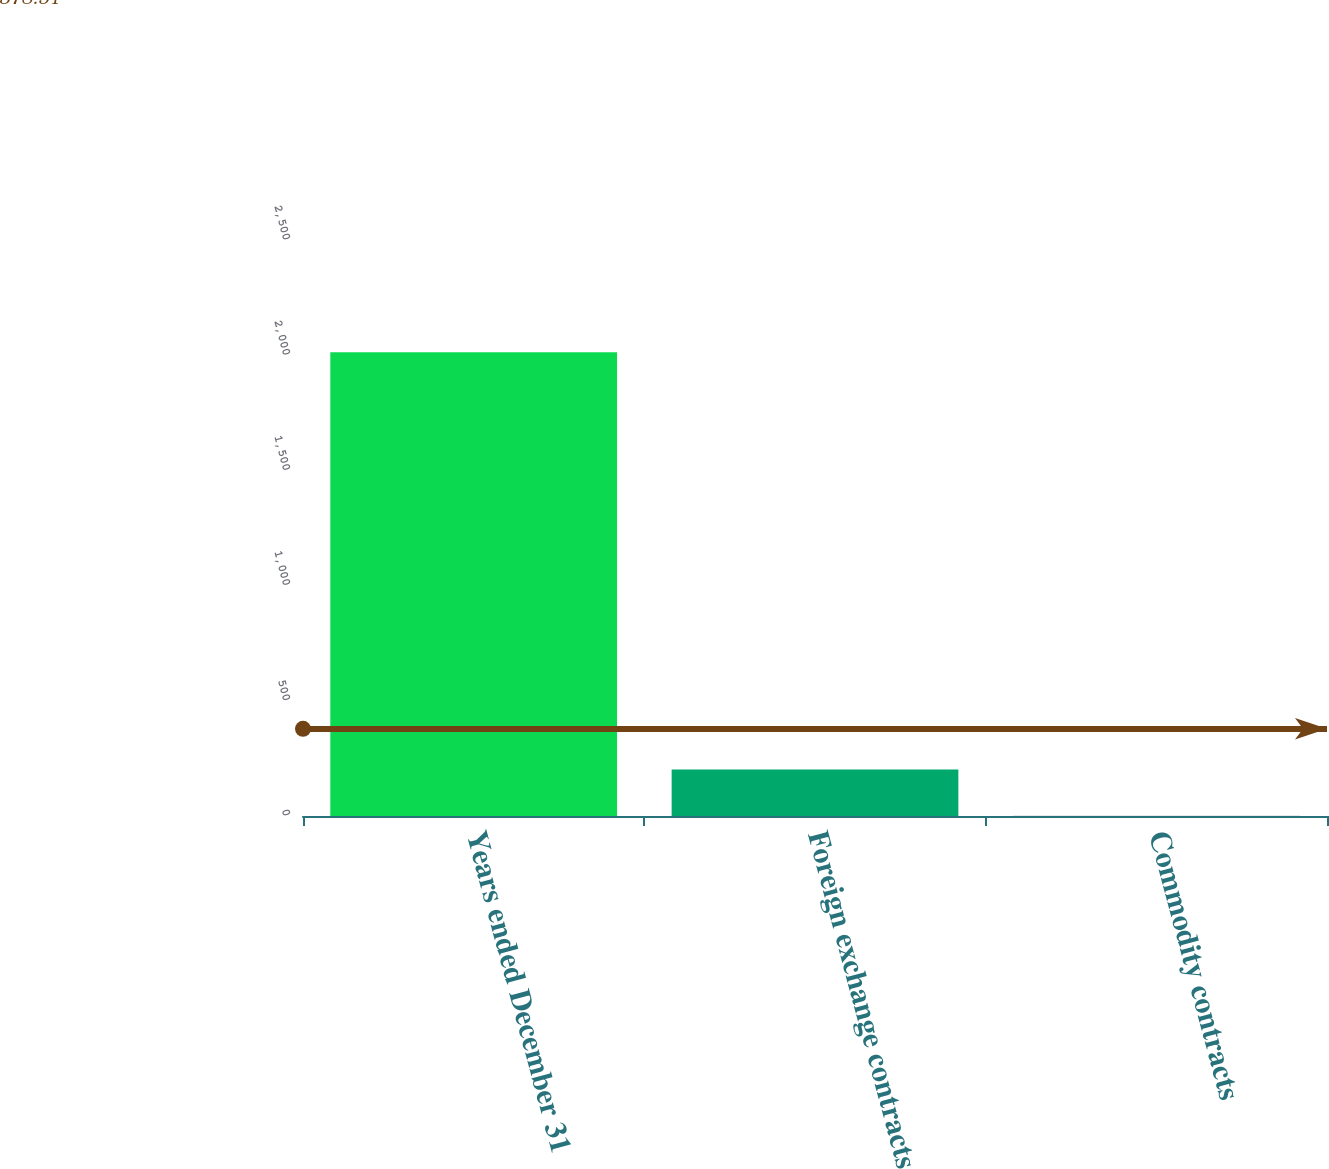<chart> <loc_0><loc_0><loc_500><loc_500><bar_chart><fcel>Years ended December 31<fcel>Foreign exchange contracts<fcel>Commodity contracts<nl><fcel>2013<fcel>202.2<fcel>1<nl></chart> 